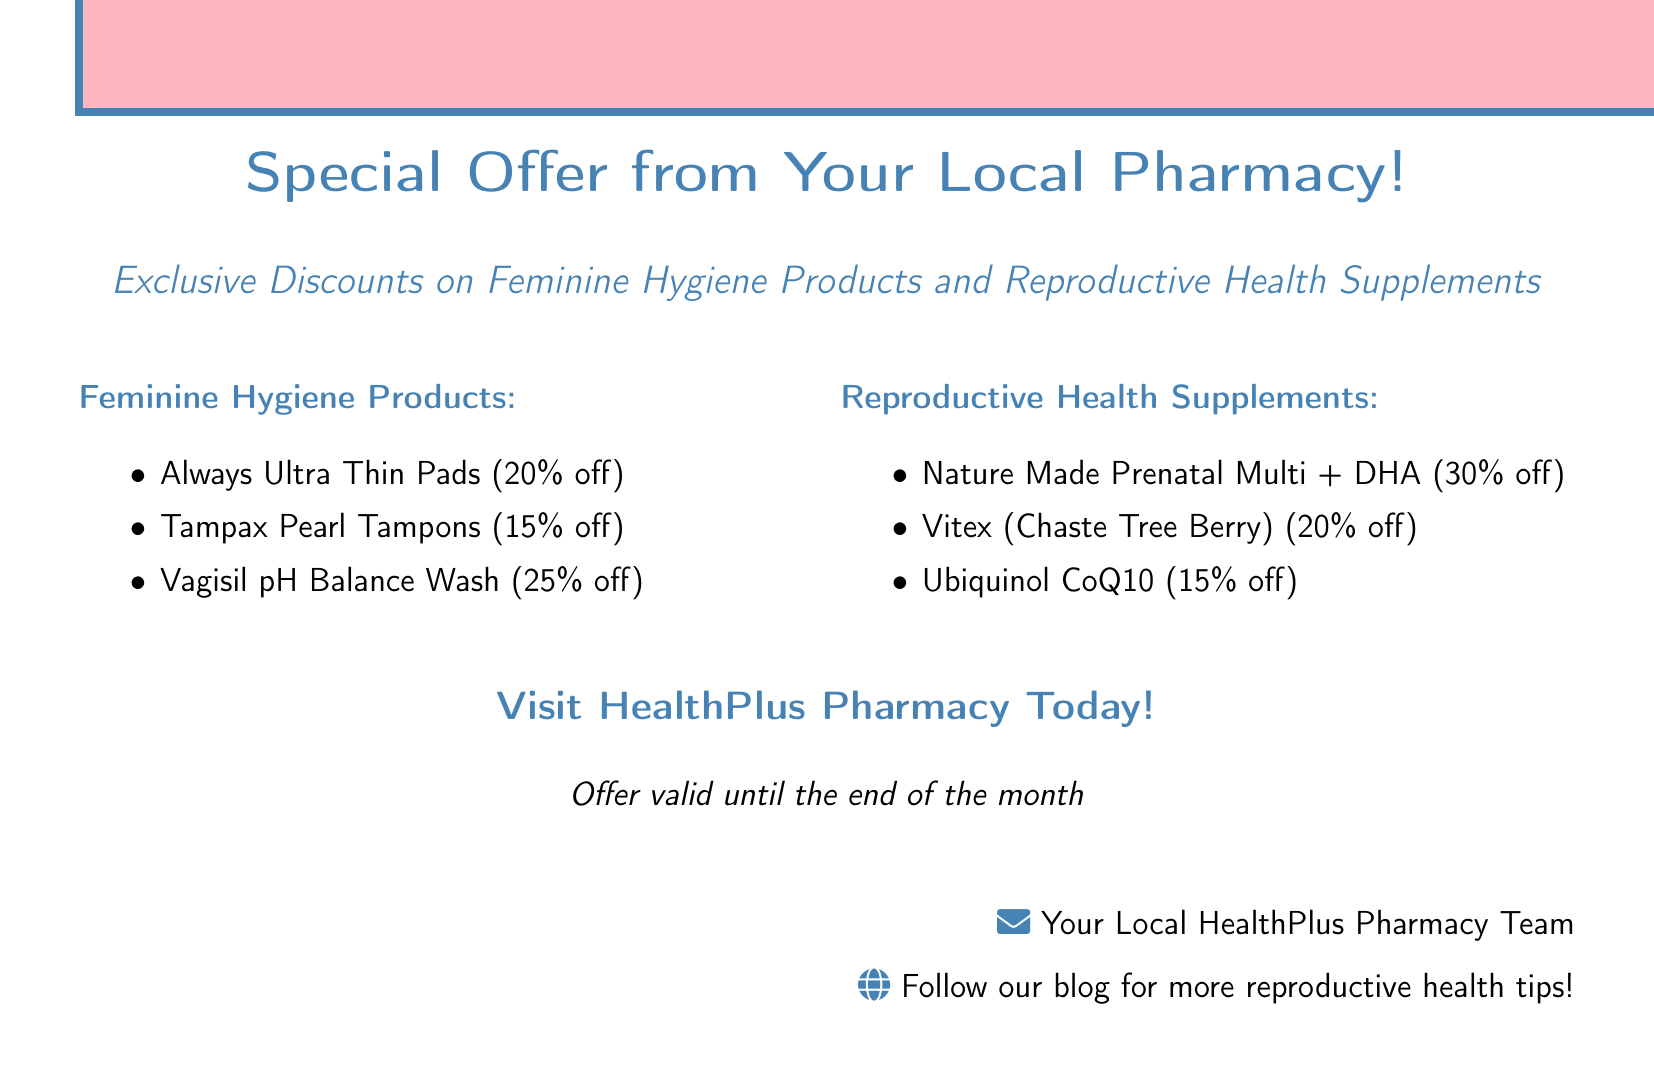What is the discount on Always Ultra Thin Pads? The discount for Always Ultra Thin Pads is specifically noted in the document as 20% off.
Answer: 20% off What is the discount on Ubiquinol CoQ10? The document states that Ubiquinol CoQ10 has a discount of 15% off.
Answer: 15% off How long is the special offer valid? The offer's validity is mentioned in the document as being until the end of the month.
Answer: Until the end of the month Which product has the highest discount among feminine hygiene products? By comparing the discounts listed, Vagisil pH Balance Wash has the highest discount of 25% off.
Answer: Vagisil pH Balance Wash What is the name of the pharmacy mentioned in the document? The document identifies the pharmacy as HealthPlus Pharmacy.
Answer: HealthPlus Pharmacy How much discount is provided on Vitex? The document specifies that Vitex (Chaste Tree Berry) is offered at a discount of 20% off.
Answer: 20% off What type of products are included in the special offer? The products included are feminine hygiene products and reproductive health supplements, as stated in the document.
Answer: Feminine hygiene products and reproductive health supplements What is the primary color theme used in the document? The document uses a consistent color theme of pink and blue for its design elements.
Answer: Pink and blue 